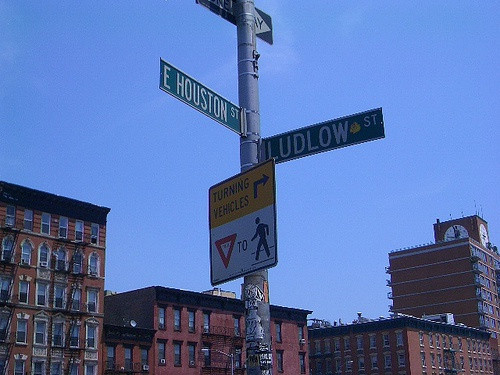Describe the objects in this image and their specific colors. I can see clock in gray, navy, and blue tones and clock in gray, darkgray, and lavender tones in this image. 